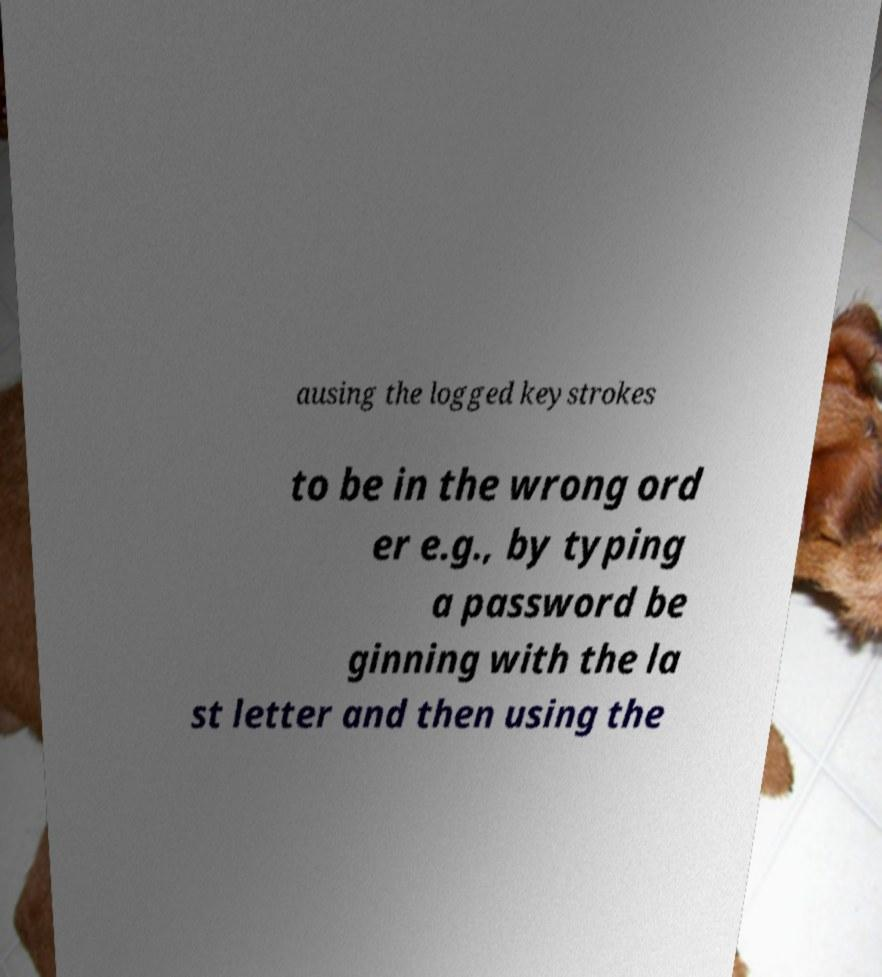Can you read and provide the text displayed in the image?This photo seems to have some interesting text. Can you extract and type it out for me? ausing the logged keystrokes to be in the wrong ord er e.g., by typing a password be ginning with the la st letter and then using the 